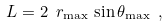<formula> <loc_0><loc_0><loc_500><loc_500>L = 2 \ r _ { \max } \, \sin \theta _ { \max } \ ,</formula> 